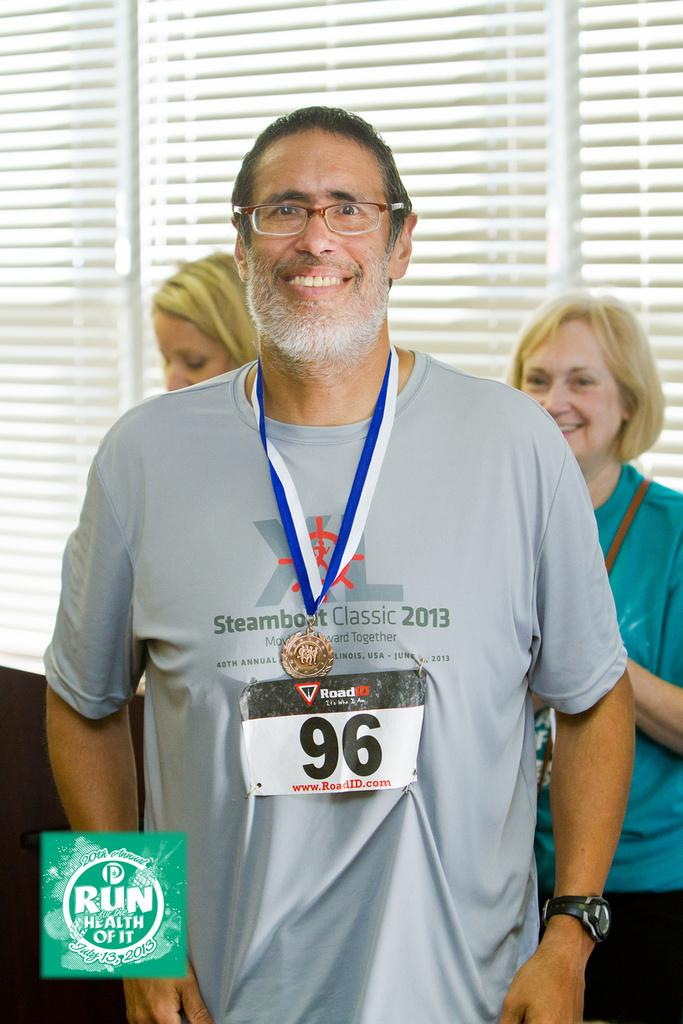<image>
Summarize the visual content of the image. A man wearing his Steamboat Classic shirt is proudly displaying his finishing medal. 